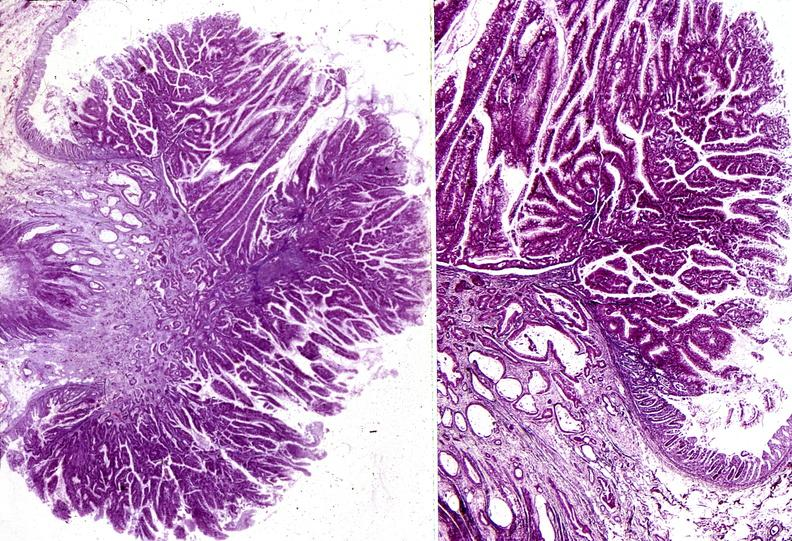what does this image show?
Answer the question using a single word or phrase. Colon 